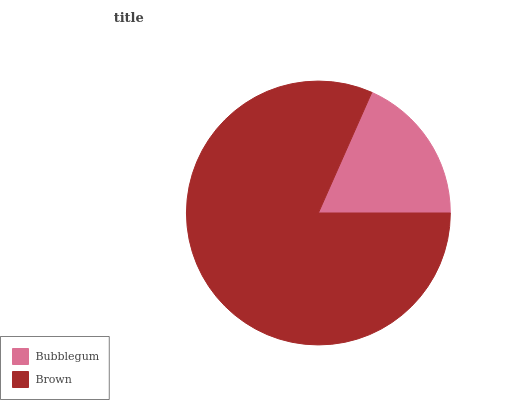Is Bubblegum the minimum?
Answer yes or no. Yes. Is Brown the maximum?
Answer yes or no. Yes. Is Brown the minimum?
Answer yes or no. No. Is Brown greater than Bubblegum?
Answer yes or no. Yes. Is Bubblegum less than Brown?
Answer yes or no. Yes. Is Bubblegum greater than Brown?
Answer yes or no. No. Is Brown less than Bubblegum?
Answer yes or no. No. Is Brown the high median?
Answer yes or no. Yes. Is Bubblegum the low median?
Answer yes or no. Yes. Is Bubblegum the high median?
Answer yes or no. No. Is Brown the low median?
Answer yes or no. No. 